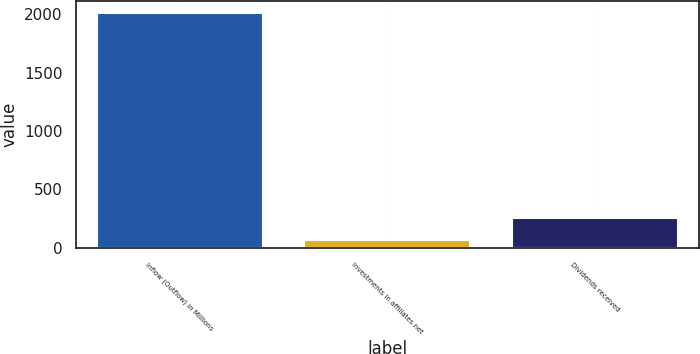<chart> <loc_0><loc_0><loc_500><loc_500><bar_chart><fcel>Inflow (Outflow) in Millions<fcel>Investments in affiliates net<fcel>Dividends received<nl><fcel>2016<fcel>63.9<fcel>259.11<nl></chart> 